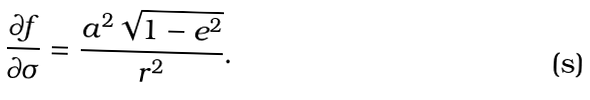<formula> <loc_0><loc_0><loc_500><loc_500>\frac { \partial f } { \partial \sigma } = \frac { a ^ { 2 } \sqrt { 1 - e ^ { 2 } } } { r ^ { 2 } } .</formula> 